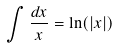Convert formula to latex. <formula><loc_0><loc_0><loc_500><loc_500>\int \frac { d x } { x } = \ln ( | x | )</formula> 